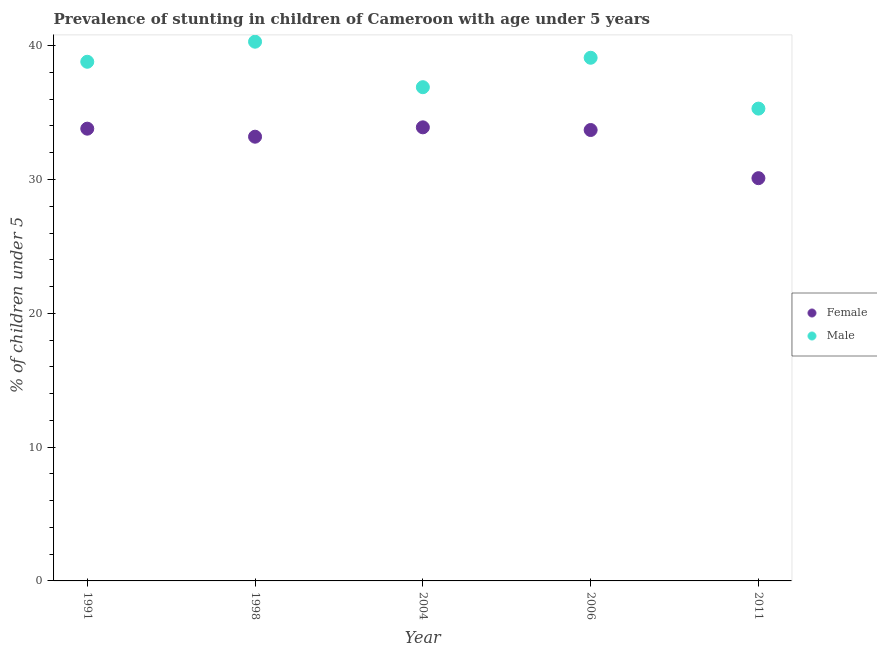How many different coloured dotlines are there?
Provide a succinct answer. 2. What is the percentage of stunted female children in 1991?
Offer a terse response. 33.8. Across all years, what is the maximum percentage of stunted male children?
Your answer should be compact. 40.3. Across all years, what is the minimum percentage of stunted female children?
Ensure brevity in your answer.  30.1. In which year was the percentage of stunted female children maximum?
Offer a terse response. 2004. In which year was the percentage of stunted male children minimum?
Ensure brevity in your answer.  2011. What is the total percentage of stunted female children in the graph?
Provide a succinct answer. 164.7. What is the difference between the percentage of stunted female children in 2006 and the percentage of stunted male children in 2004?
Ensure brevity in your answer.  -3.2. What is the average percentage of stunted female children per year?
Your answer should be compact. 32.94. In the year 2011, what is the difference between the percentage of stunted male children and percentage of stunted female children?
Your response must be concise. 5.2. In how many years, is the percentage of stunted female children greater than 32 %?
Provide a short and direct response. 4. What is the ratio of the percentage of stunted female children in 1998 to that in 2006?
Provide a short and direct response. 0.99. Is the percentage of stunted female children in 1998 less than that in 2006?
Offer a terse response. Yes. What is the difference between the highest and the second highest percentage of stunted female children?
Your response must be concise. 0.1. What is the difference between the highest and the lowest percentage of stunted male children?
Your response must be concise. 5. Does the percentage of stunted male children monotonically increase over the years?
Provide a succinct answer. No. Is the percentage of stunted male children strictly greater than the percentage of stunted female children over the years?
Provide a short and direct response. Yes. Is the percentage of stunted male children strictly less than the percentage of stunted female children over the years?
Your answer should be very brief. No. How many years are there in the graph?
Keep it short and to the point. 5. Does the graph contain any zero values?
Provide a succinct answer. No. Does the graph contain grids?
Your answer should be very brief. No. Where does the legend appear in the graph?
Offer a terse response. Center right. How many legend labels are there?
Your response must be concise. 2. How are the legend labels stacked?
Keep it short and to the point. Vertical. What is the title of the graph?
Make the answer very short. Prevalence of stunting in children of Cameroon with age under 5 years. What is the label or title of the Y-axis?
Give a very brief answer.  % of children under 5. What is the  % of children under 5 of Female in 1991?
Ensure brevity in your answer.  33.8. What is the  % of children under 5 of Male in 1991?
Provide a succinct answer. 38.8. What is the  % of children under 5 of Female in 1998?
Keep it short and to the point. 33.2. What is the  % of children under 5 in Male in 1998?
Make the answer very short. 40.3. What is the  % of children under 5 in Female in 2004?
Make the answer very short. 33.9. What is the  % of children under 5 of Male in 2004?
Keep it short and to the point. 36.9. What is the  % of children under 5 of Female in 2006?
Ensure brevity in your answer.  33.7. What is the  % of children under 5 of Male in 2006?
Ensure brevity in your answer.  39.1. What is the  % of children under 5 of Female in 2011?
Your response must be concise. 30.1. What is the  % of children under 5 of Male in 2011?
Give a very brief answer. 35.3. Across all years, what is the maximum  % of children under 5 in Female?
Give a very brief answer. 33.9. Across all years, what is the maximum  % of children under 5 in Male?
Offer a very short reply. 40.3. Across all years, what is the minimum  % of children under 5 in Female?
Offer a terse response. 30.1. Across all years, what is the minimum  % of children under 5 of Male?
Provide a succinct answer. 35.3. What is the total  % of children under 5 of Female in the graph?
Provide a short and direct response. 164.7. What is the total  % of children under 5 of Male in the graph?
Keep it short and to the point. 190.4. What is the difference between the  % of children under 5 of Female in 1991 and that in 2006?
Your answer should be compact. 0.1. What is the difference between the  % of children under 5 of Female in 1991 and that in 2011?
Provide a succinct answer. 3.7. What is the difference between the  % of children under 5 in Female in 1998 and that in 2004?
Your response must be concise. -0.7. What is the difference between the  % of children under 5 of Male in 1998 and that in 2004?
Your answer should be compact. 3.4. What is the difference between the  % of children under 5 of Male in 1998 and that in 2011?
Ensure brevity in your answer.  5. What is the difference between the  % of children under 5 in Female in 2004 and that in 2006?
Give a very brief answer. 0.2. What is the difference between the  % of children under 5 in Female in 2004 and that in 2011?
Give a very brief answer. 3.8. What is the difference between the  % of children under 5 of Female in 2006 and that in 2011?
Your response must be concise. 3.6. What is the difference between the  % of children under 5 in Male in 2006 and that in 2011?
Offer a terse response. 3.8. What is the difference between the  % of children under 5 of Female in 1991 and the  % of children under 5 of Male in 2006?
Give a very brief answer. -5.3. What is the average  % of children under 5 of Female per year?
Your answer should be very brief. 32.94. What is the average  % of children under 5 of Male per year?
Ensure brevity in your answer.  38.08. In the year 2006, what is the difference between the  % of children under 5 of Female and  % of children under 5 of Male?
Your answer should be very brief. -5.4. What is the ratio of the  % of children under 5 in Female in 1991 to that in 1998?
Your response must be concise. 1.02. What is the ratio of the  % of children under 5 in Male in 1991 to that in 1998?
Give a very brief answer. 0.96. What is the ratio of the  % of children under 5 in Female in 1991 to that in 2004?
Offer a very short reply. 1. What is the ratio of the  % of children under 5 of Male in 1991 to that in 2004?
Make the answer very short. 1.05. What is the ratio of the  % of children under 5 in Female in 1991 to that in 2011?
Provide a succinct answer. 1.12. What is the ratio of the  % of children under 5 of Male in 1991 to that in 2011?
Give a very brief answer. 1.1. What is the ratio of the  % of children under 5 of Female in 1998 to that in 2004?
Offer a very short reply. 0.98. What is the ratio of the  % of children under 5 of Male in 1998 to that in 2004?
Ensure brevity in your answer.  1.09. What is the ratio of the  % of children under 5 in Female in 1998 to that in 2006?
Your answer should be very brief. 0.99. What is the ratio of the  % of children under 5 in Male in 1998 to that in 2006?
Provide a short and direct response. 1.03. What is the ratio of the  % of children under 5 of Female in 1998 to that in 2011?
Offer a terse response. 1.1. What is the ratio of the  % of children under 5 of Male in 1998 to that in 2011?
Make the answer very short. 1.14. What is the ratio of the  % of children under 5 in Female in 2004 to that in 2006?
Provide a short and direct response. 1.01. What is the ratio of the  % of children under 5 in Male in 2004 to that in 2006?
Your answer should be compact. 0.94. What is the ratio of the  % of children under 5 in Female in 2004 to that in 2011?
Keep it short and to the point. 1.13. What is the ratio of the  % of children under 5 in Male in 2004 to that in 2011?
Your answer should be very brief. 1.05. What is the ratio of the  % of children under 5 of Female in 2006 to that in 2011?
Your answer should be very brief. 1.12. What is the ratio of the  % of children under 5 of Male in 2006 to that in 2011?
Your response must be concise. 1.11. What is the difference between the highest and the second highest  % of children under 5 in Male?
Your response must be concise. 1.2. 